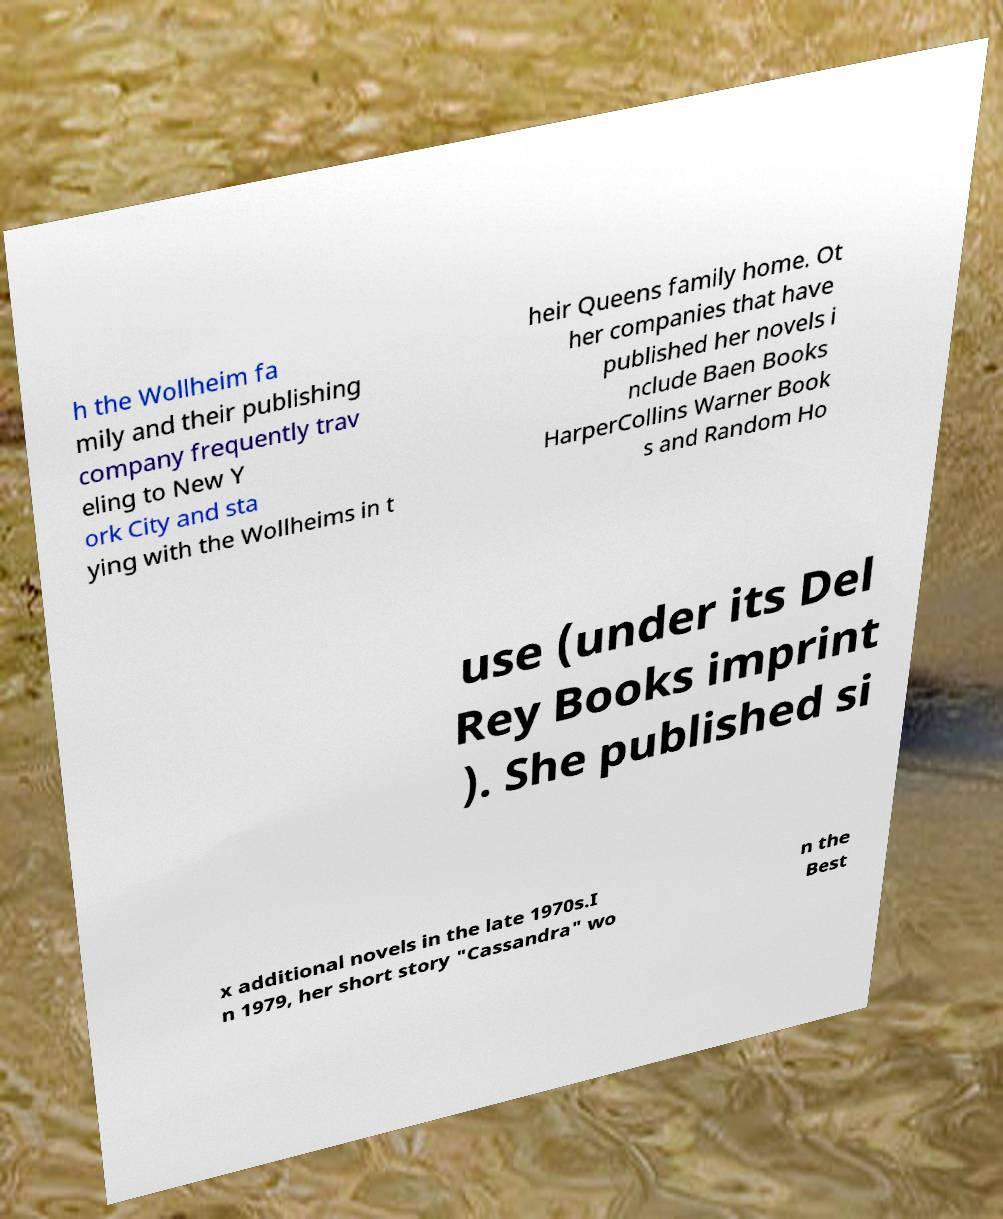I need the written content from this picture converted into text. Can you do that? h the Wollheim fa mily and their publishing company frequently trav eling to New Y ork City and sta ying with the Wollheims in t heir Queens family home. Ot her companies that have published her novels i nclude Baen Books HarperCollins Warner Book s and Random Ho use (under its Del Rey Books imprint ). She published si x additional novels in the late 1970s.I n 1979, her short story "Cassandra" wo n the Best 